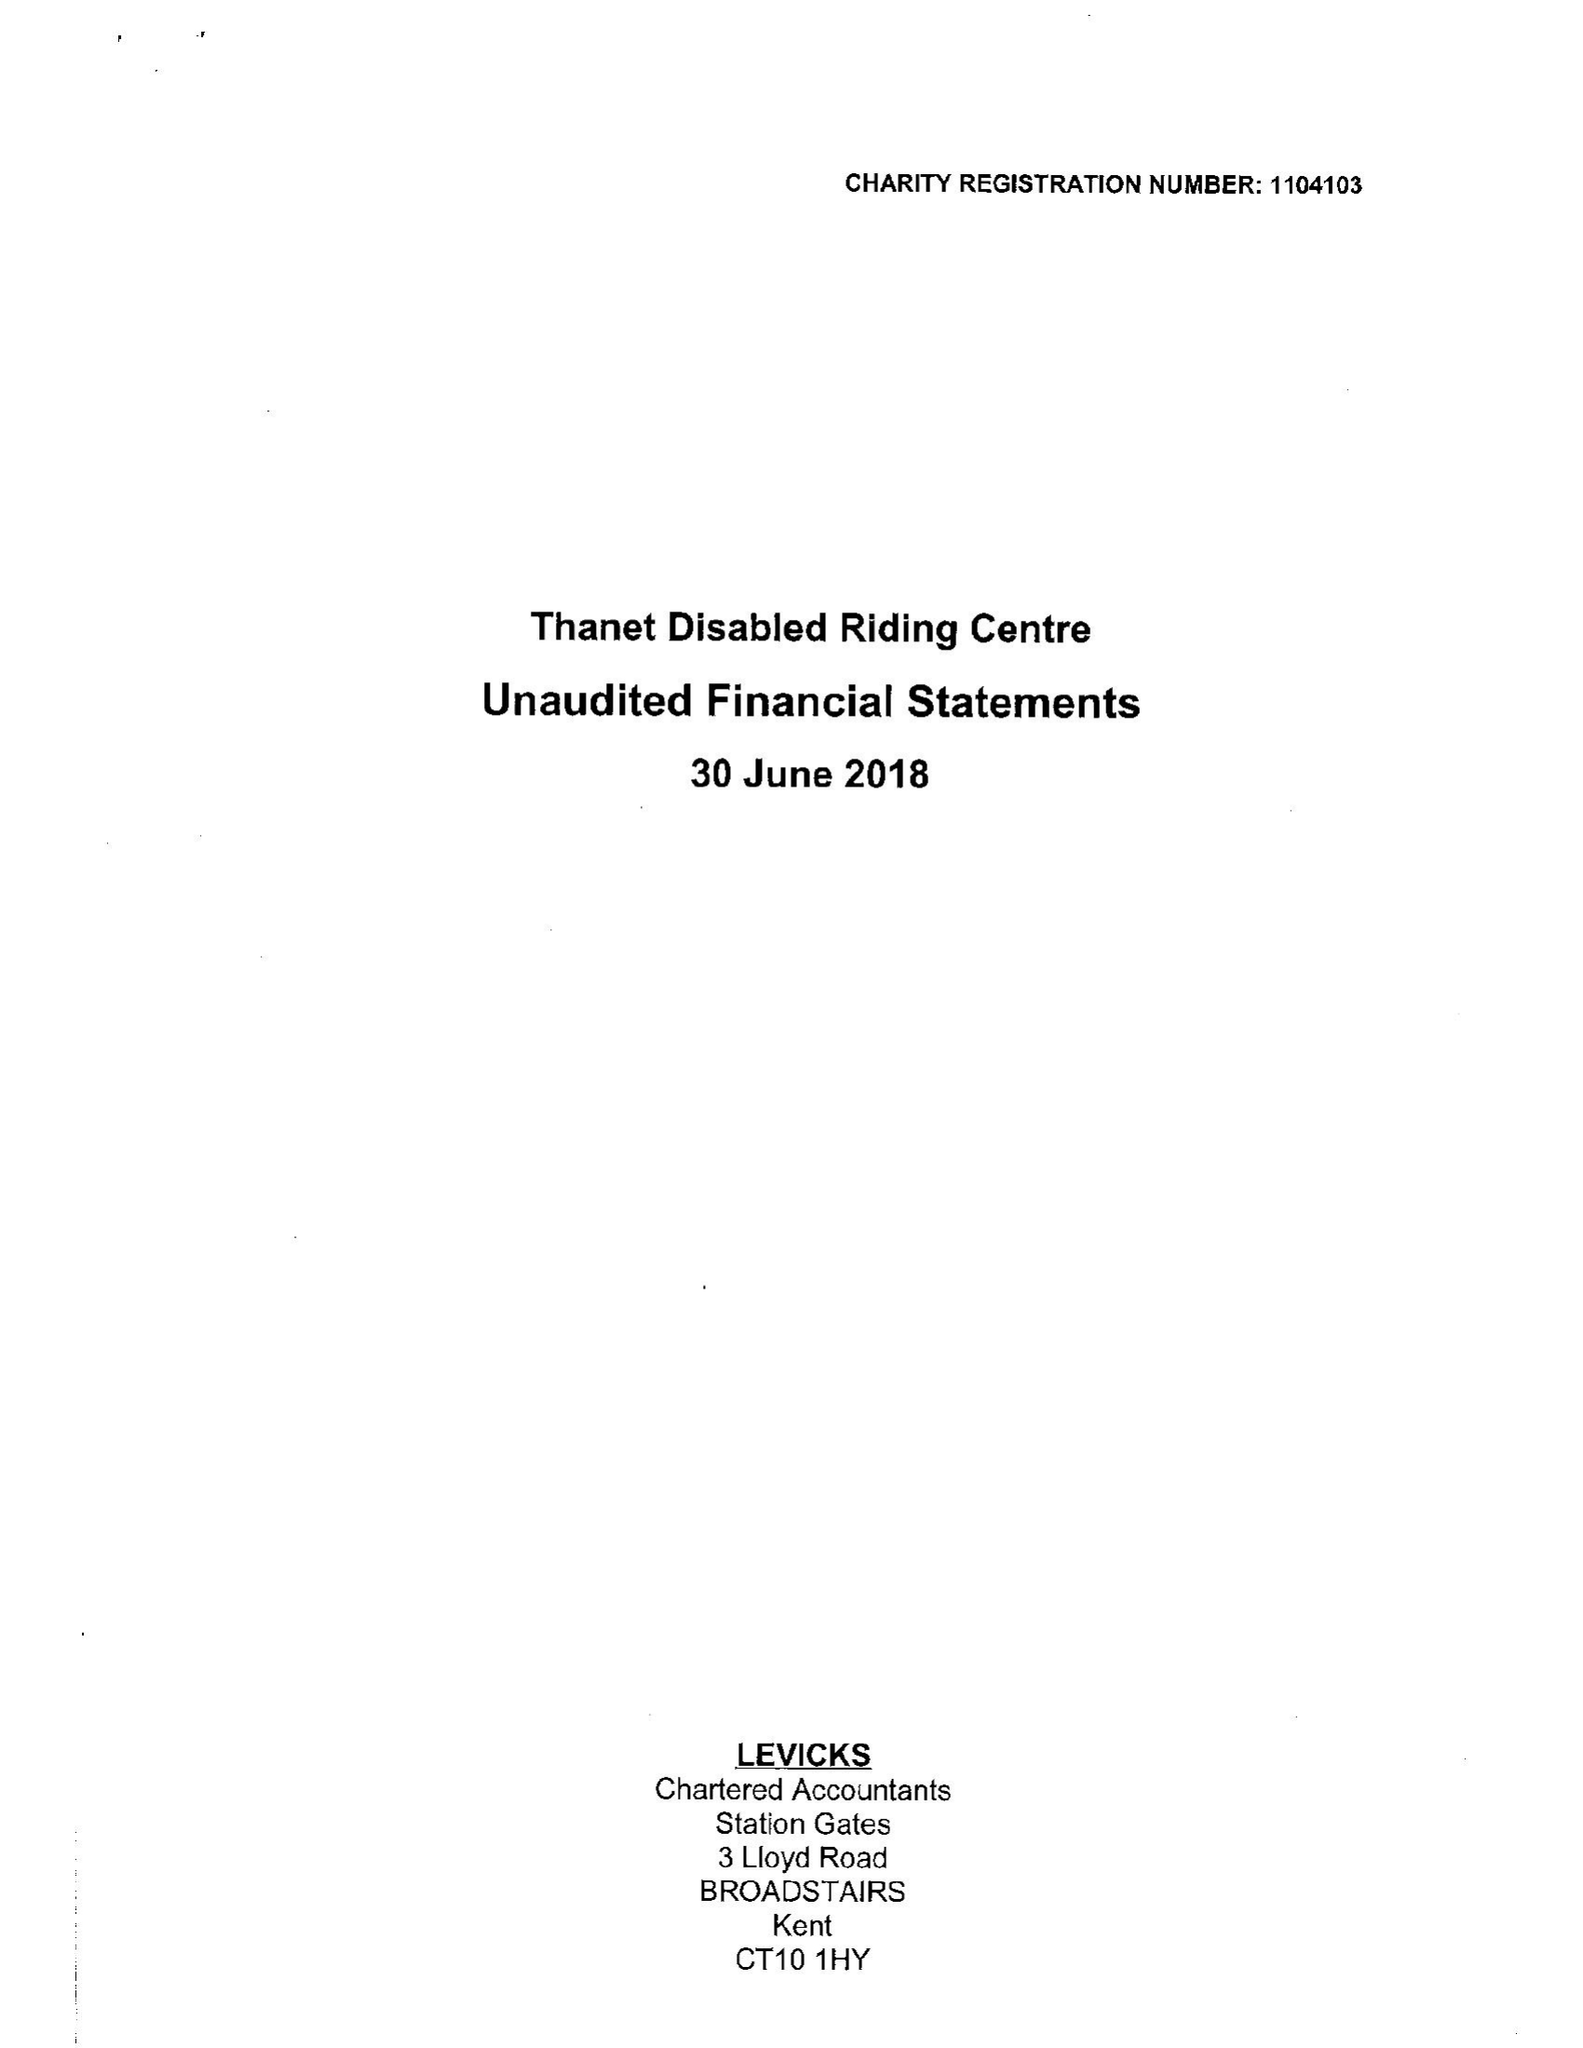What is the value for the income_annually_in_british_pounds?
Answer the question using a single word or phrase. 31950.00 